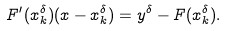<formula> <loc_0><loc_0><loc_500><loc_500>F ^ { \prime } ( x _ { k } ^ { \delta } ) ( x - x _ { k } ^ { \delta } ) = y ^ { \delta } - F ( x _ { k } ^ { \delta } ) .</formula> 